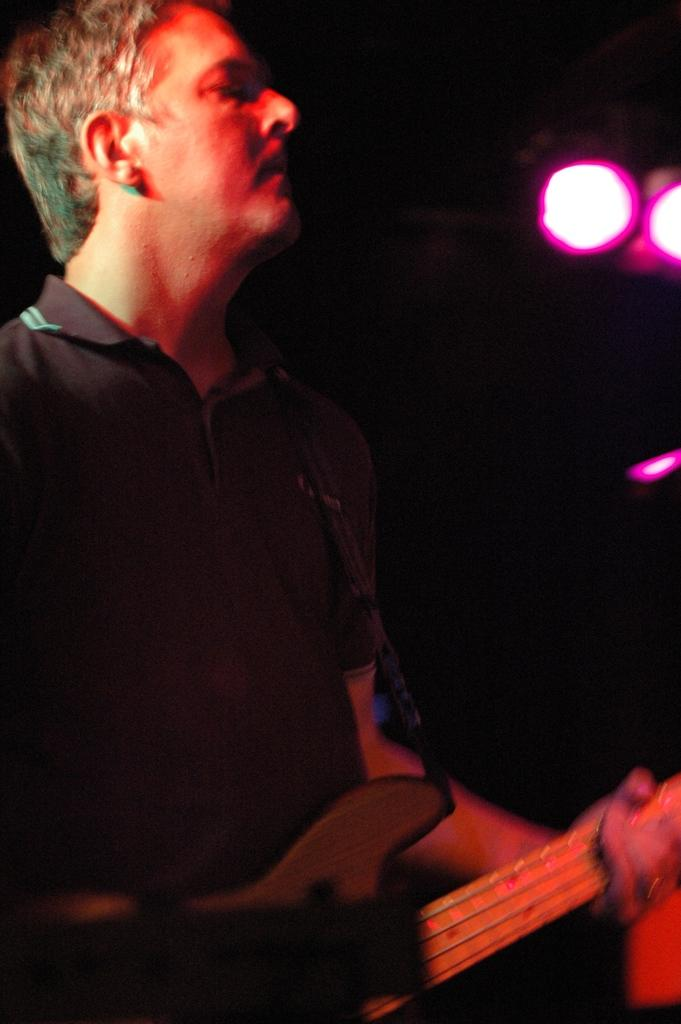What is the man in the image doing? The man is playing the guitar in the image. How is the man playing the guitar? The man is using his hand to play the guitar. What can be seen at the top of the image? There are lights visible at the top of the image. How many rabbits can be seen playing the guitar in the image? There are no rabbits present in the image, and the man is the only one playing the guitar. Is the guitar playing stopped in the image? No, the guitar playing is not stopped in the image; the man is actively playing the guitar. 